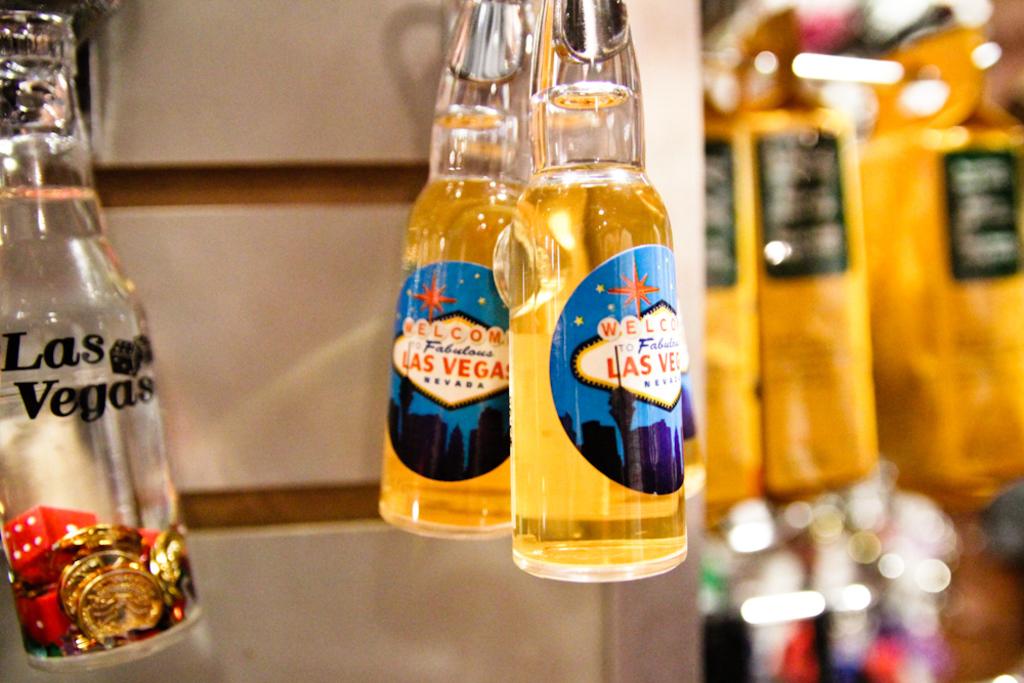What city are these bottles from?
Make the answer very short. Las vegas. 